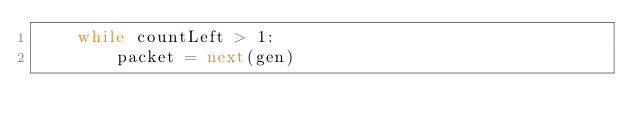<code> <loc_0><loc_0><loc_500><loc_500><_Python_>    while countLeft > 1:
        packet = next(gen)</code> 